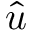Convert formula to latex. <formula><loc_0><loc_0><loc_500><loc_500>\hat { u }</formula> 